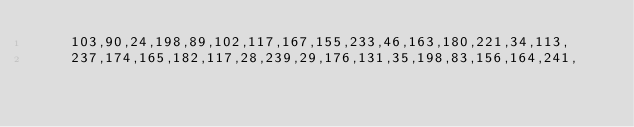<code> <loc_0><loc_0><loc_500><loc_500><_C++_>    103,90,24,198,89,102,117,167,155,233,46,163,180,221,34,113,
    237,174,165,182,117,28,239,29,176,131,35,198,83,156,164,241,</code> 